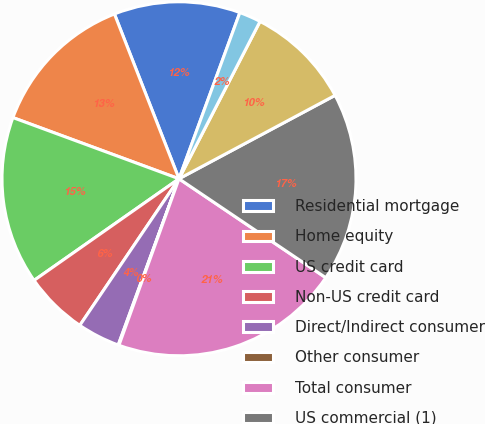Convert chart. <chart><loc_0><loc_0><loc_500><loc_500><pie_chart><fcel>Residential mortgage<fcel>Home equity<fcel>US credit card<fcel>Non-US credit card<fcel>Direct/Indirect consumer<fcel>Other consumer<fcel>Total consumer<fcel>US commercial (1)<fcel>Commercial real estate<fcel>Commercial lease financing<nl><fcel>11.53%<fcel>13.44%<fcel>15.35%<fcel>5.8%<fcel>3.89%<fcel>0.07%<fcel>21.07%<fcel>17.25%<fcel>9.62%<fcel>1.98%<nl></chart> 